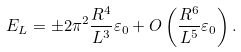Convert formula to latex. <formula><loc_0><loc_0><loc_500><loc_500>E _ { L } = \pm 2 \pi ^ { 2 } \frac { R ^ { 4 } } { L ^ { 3 } } \varepsilon _ { 0 } + O \left ( \frac { R ^ { 6 } } { L ^ { 5 } } \varepsilon _ { 0 } \right ) .</formula> 